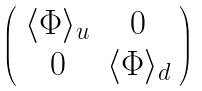Convert formula to latex. <formula><loc_0><loc_0><loc_500><loc_500>\left ( \begin{array} { c c } \langle \Phi \rangle _ { u } & 0 \\ 0 & \langle \Phi \rangle _ { d } \\ \end{array} \right ) \,</formula> 